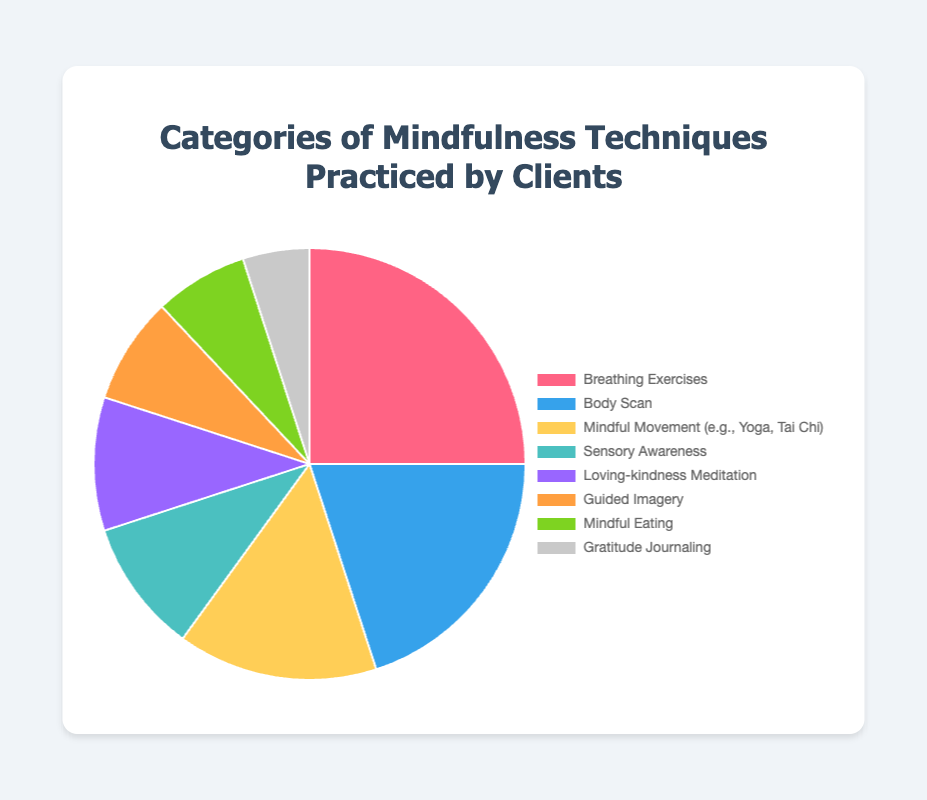What's the total percentage of techniques practiced by clients? Add the percentages of all techniques: 25% + 20% + 15% + 10% + 10% + 8% + 7% + 5% = 100%.
Answer: 100% Which mindfulness technique is practiced the most by clients? The 'Breathing Exercises' technique has the highest percentage at 25%.
Answer: Breathing Exercises Which two techniques have the same percentage? 'Sensory Awareness' and 'Loving-kindness Meditation' both have a percentage of 10%.
Answer: Sensory Awareness and Loving-kindness Meditation What is the difference in percentage between 'Body Scan' and 'Guided Imagery'? 'Body Scan' is 20% and 'Guided Imagery' is 8%, so the difference is 20% - 8% = 12%.
Answer: 12% Compare 'Mindful Eating' and 'Gratitude Journaling'. Which is practiced more? 'Mindful Eating' has a percentage of 7%, whereas 'Gratitude Journaling' has 5%, making 'Mindful Eating' practiced more.
Answer: Mindful Eating Calculate the combined percentage for 'Guided Imagery' and 'Mindful Eating'. Add the percentages: 8% (Guided Imagery) + 7% (Mindful Eating) = 15%.
Answer: 15% What's the percentage of all movement-related techniques practiced (e.g., Yoga, Tai Chi)? Only 'Mindful Movement' fits this category and it is 15%.
Answer: 15% What color represents 'Mindful Movement' in the chart? The 'Mindful Movement' section in the pie chart is represented by a specific color, which is likely 'Yellow' based on common color associations.
Answer: Yellow What is the sum of the percentages for 'Breathing Exercises', 'Body Scan', and 'Mindful Movement'? Add the percentages: 25% (Breathing Exercises) + 20% (Body Scan) + 15% (Mindful Movement) = 60%.
Answer: 60% Which has a smaller percentage: 'Sensory Awareness' or 'Mindful Eating'? 'Sensory Awareness' is 10% while 'Mindful Eating' is 7%, meaning 'Mindful Eating' has a smaller percentage.
Answer: Mindful Eating 